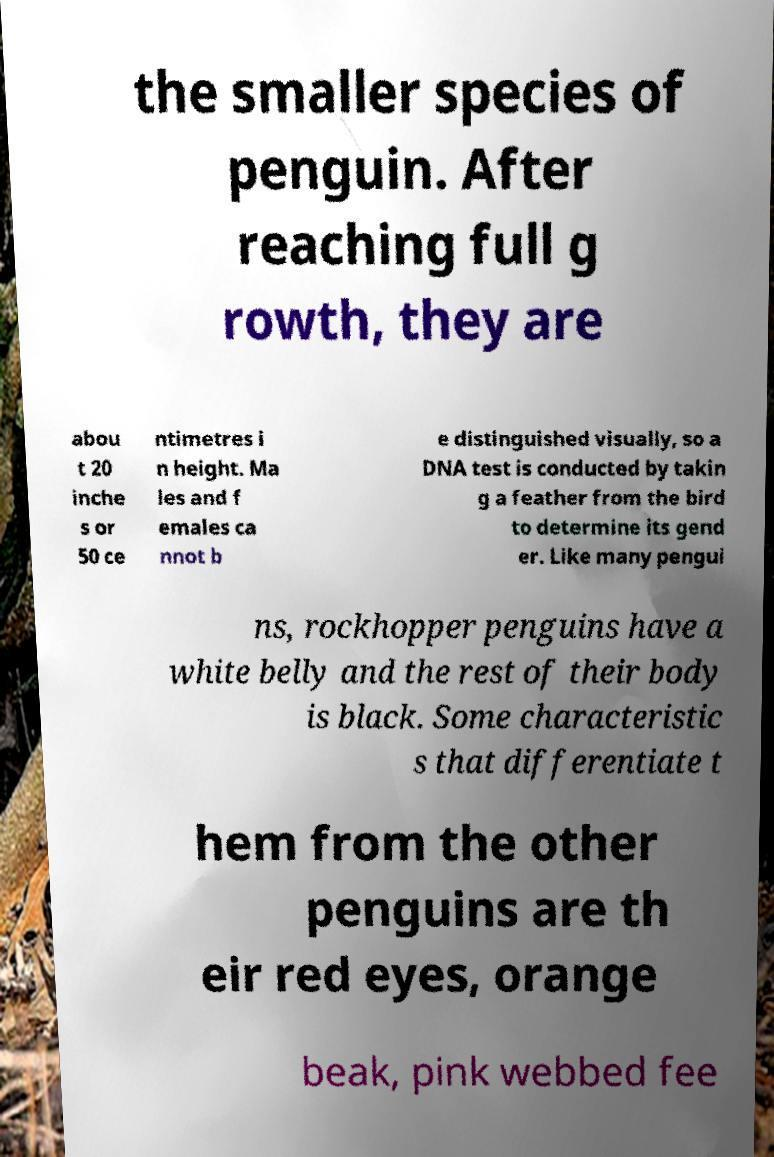Please identify and transcribe the text found in this image. the smaller species of penguin. After reaching full g rowth, they are abou t 20 inche s or 50 ce ntimetres i n height. Ma les and f emales ca nnot b e distinguished visually, so a DNA test is conducted by takin g a feather from the bird to determine its gend er. Like many pengui ns, rockhopper penguins have a white belly and the rest of their body is black. Some characteristic s that differentiate t hem from the other penguins are th eir red eyes, orange beak, pink webbed fee 